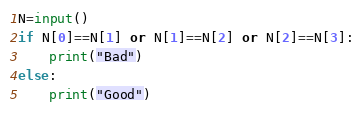Convert code to text. <code><loc_0><loc_0><loc_500><loc_500><_Python_>N=input()
if N[0]==N[1] or N[1]==N[2] or N[2]==N[3]:
    print("Bad")
else:
    print("Good")</code> 